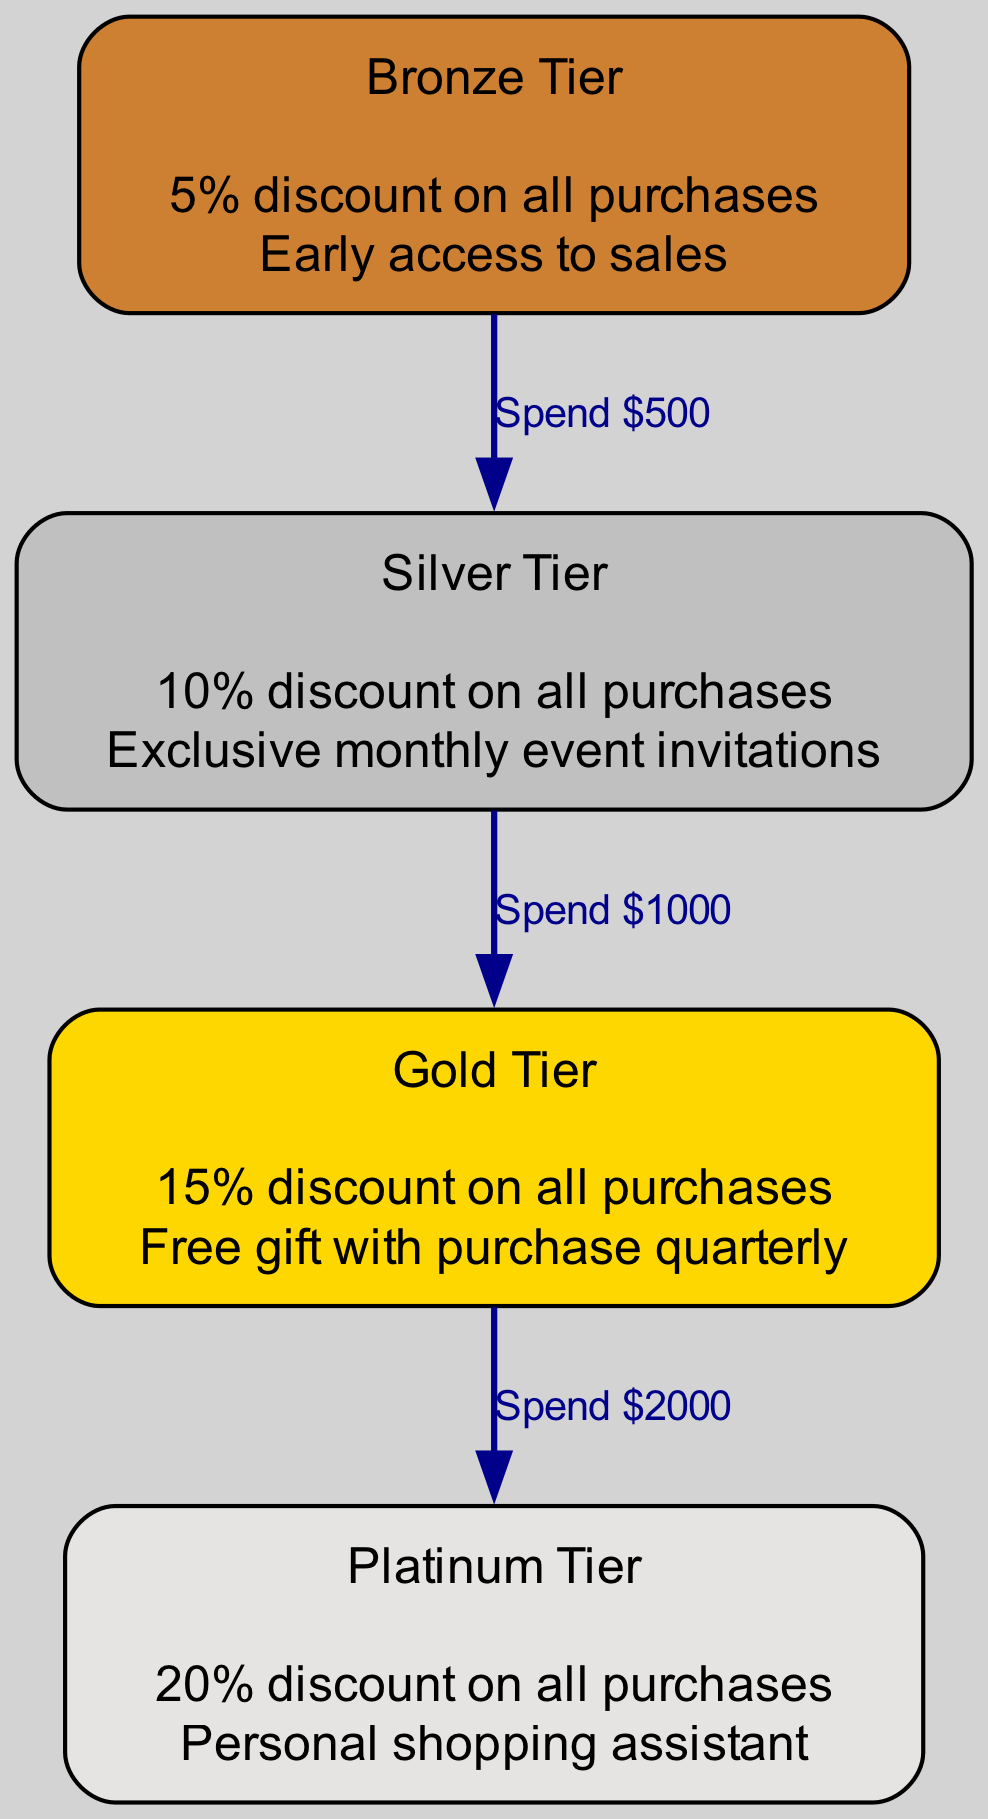What perks do Silver Tier customers receive? The diagram lists the perks associated with the Silver Tier directly beneath its name. The perks are: "10% discount on all purchases" and "Exclusive monthly event invitations."
Answer: 10% discount on all purchases, Exclusive monthly event invitations How many tiers are shown in the diagram? By counting the unique tiers present in the diagram, we see Bronze, Silver, Gold, and Platinum, leading to a total of 4 tiers.
Answer: 4 What is the minimum spending required to reach Gold Tier? To achieve Gold Tier, one must first move from Silver Tier, which requires spending $1000. Therefore, the total minimum spending required is $500 (to reach Silver) + $1000 (to reach Gold) = $1500.
Answer: $1500 What discount does Platinum Tier offer? The discount associated with the Platinum Tier is displayed directly under its name in the diagram, indicating that Platinum Tier offers a "20% discount on all purchases."
Answer: 20% discount on all purchases How do you progress from Silver Tier to Gold Tier? To progress from Silver Tier to Gold Tier, one must spend $1000, as indicated by the connecting edge labeled "Spend $1000" between the Silver and Gold Tiers.
Answer: Spend $1000 What is the relationship between Bronze Tier and Silver Tier? The relationship between Bronze Tier and Silver Tier is defined by the edge labeled "Spend $500," indicating that reaching Silver Tier requires a spending of $500.
Answer: Spend $500 Which tier has the highest discount percentage? The Gold Tier has the highest discount among the tiers shown in the diagram, offering a "15% discount on all purchases," which is greater than the discounts provided by Bronze, Silver, and Platinum Tiers.
Answer: Gold Tier What perk do Gold Tier members receive quarterly? The diagram shows that Gold Tier members receive "Free gift with purchase quarterly," which is one of the perks listed directly beneath the Gold Tier.
Answer: Free gift with purchase quarterly 